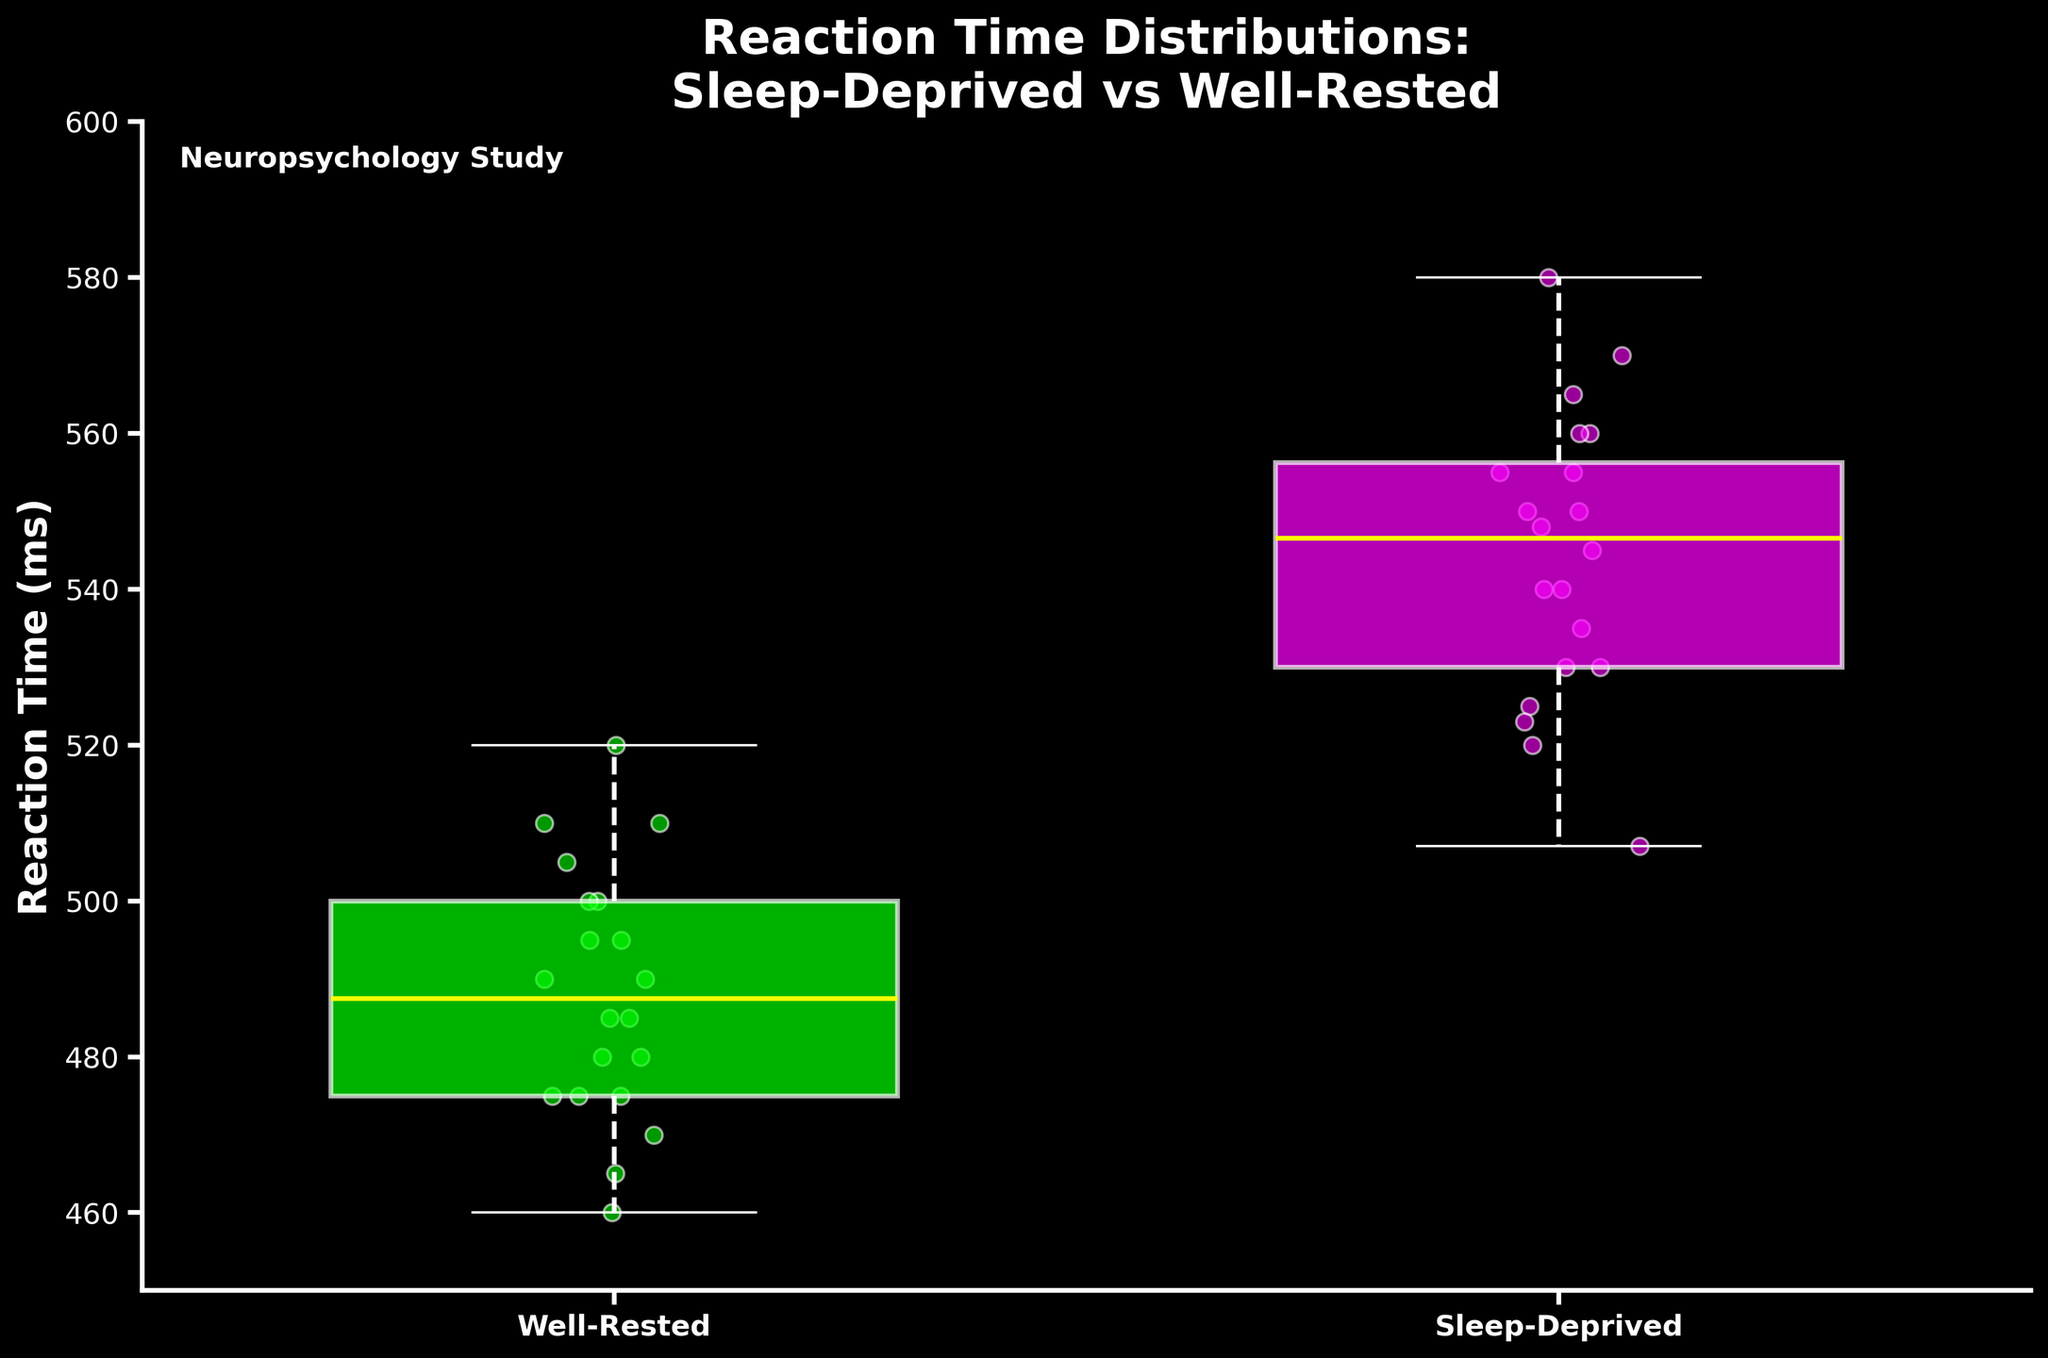What are the two conditions compared in this figure? The x-axis labels display the conditions being compared. They are labeled as 'Well-Rested' and 'Sleep-Deprived'.
Answer: Well-Rested, Sleep-Deprived Which color represents the reaction-time distribution for the Sleep-Deprived participants? The plot's legend or visual representation distinguishes the colors associated with each condition. The Sleep-Deprived group is represented by a magenta color.
Answer: Magenta What is the title of the plot? The title appears at the top of the figure and reads 'Reaction Time Distributions: Sleep-Deprived vs Well-Rested'.
Answer: Reaction Time Distributions: Sleep-Deprived vs Well-Rested Which group shows a higher median reaction time? The median is marked by the horizontal line within each box. By comparing the positions of these lines between the two boxes, one can see the Sleep-Deprived group has a higher median reaction time.
Answer: Sleep-Deprived What is the approximate range of reaction times for the Sleep-Deprived group? The range can be estimated by observing the whiskers of the Sleep-Deprived box plot. They span approximately from 507 to 580 milliseconds.
Answer: 507 to 580 ms How does the median reaction time of Well-Rested participants compare to the lower quartile of Sleep-Deprived participants? Compare the median line in the Well-Rested box plot with the lower quartile (bottom edge of the box) in the Sleep-Deprived box plot. The median reaction time of Well-Rested participants is lower than the lower quartile of Sleep-Deprived participants.
Answer: Lower Are there any outliers in the data for either condition? Outliers would be displayed as individual points outside the whiskers. There are no such points visible for either Well-Rested or Sleep-Deprived participants.
Answer: No Which group has a higher maximum reaction time? The maximum is indicated by the top whisker. The Sleep-Deprived group has a higher maximum reaction time compared to the Well-Rested group.
Answer: Sleep-Deprived What is the minimum reaction time observed in Well-Rested participants, and how does it compare to the Sleep-Deprived participants? The minimum is indicated by the bottom whisker of each box plot. The Well-Rested group has a minimum reaction time of around 460 milliseconds, whereas the Sleep-Deprived group's minimum is around 507 milliseconds, making the Well-Rested group's minimum lower.
Answer: Well-Rested is lower What conclusion could we possibly draw about the effect of sleep deprivation on reaction time based on this plot? By examining the medians, ranges, and general spread of the box plots, it suggests that sleep deprivation tends to increase reaction time, as the Sleep-Deprived group has consistently higher reaction times than the Well-Rested group.
Answer: Sleep deprivation increases reaction time 